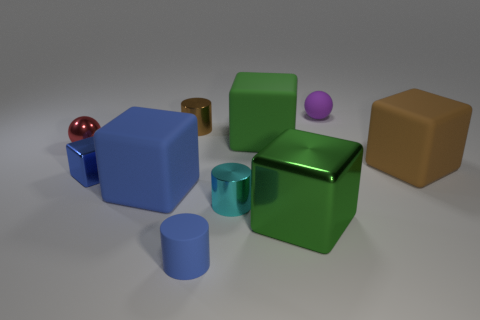Subtract all big blue rubber cubes. How many cubes are left? 4 Subtract 1 cubes. How many cubes are left? 4 Subtract all brown blocks. How many blocks are left? 4 Subtract all yellow blocks. Subtract all green balls. How many blocks are left? 5 Subtract all cylinders. How many objects are left? 7 Subtract all large rubber blocks. Subtract all large yellow blocks. How many objects are left? 7 Add 6 cyan cylinders. How many cyan cylinders are left? 7 Add 7 small cyan blocks. How many small cyan blocks exist? 7 Subtract 0 gray cylinders. How many objects are left? 10 